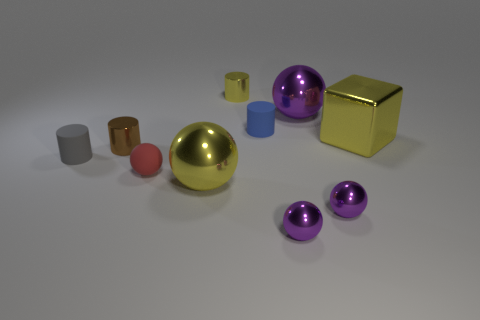Could you tell me the position and color of the largest object? The largest object is a gold-colored sphere located near the center of the image. Are there any patterns or designs on any of the objects? The objects are solid colored and do not have any visible patterns or designs on their surfaces. 